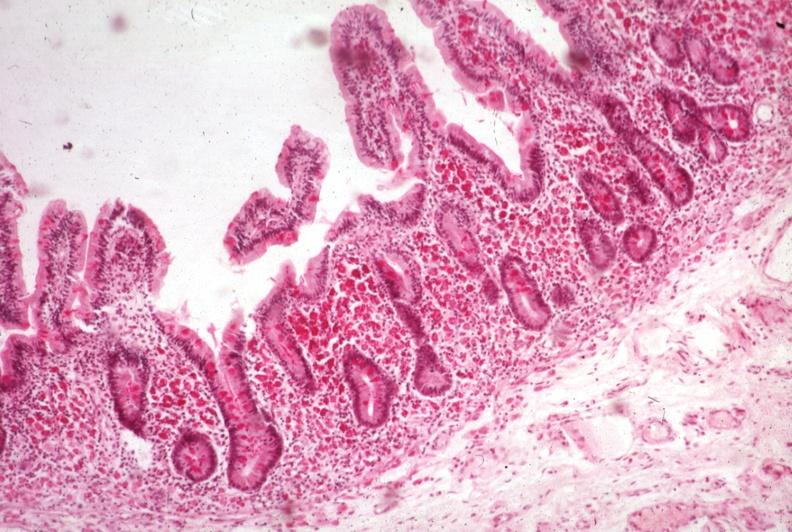s pus in test tube present?
Answer the question using a single word or phrase. No 